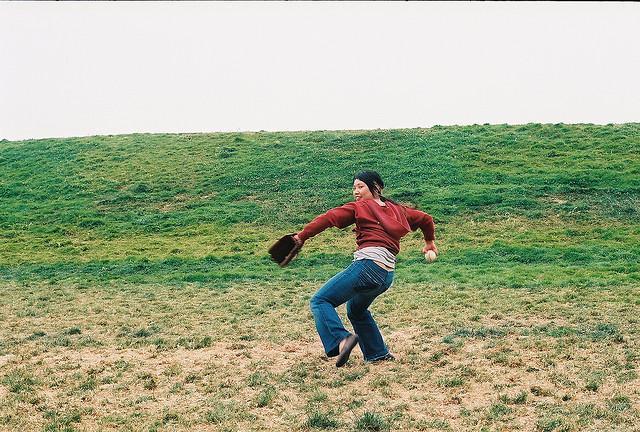How many flags are seen?
Give a very brief answer. 0. 